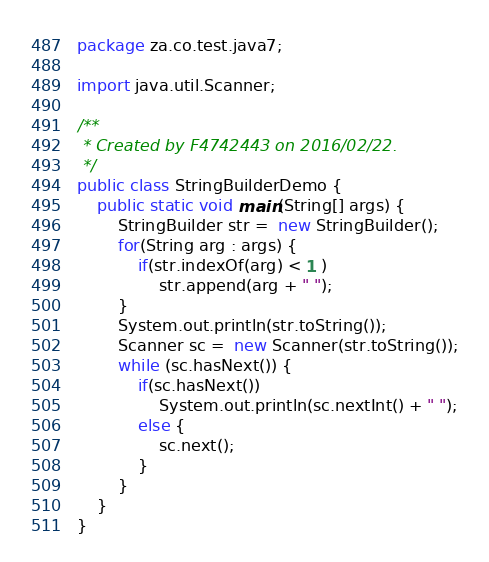Convert code to text. <code><loc_0><loc_0><loc_500><loc_500><_Java_>package za.co.test.java7;

import java.util.Scanner;

/**
 * Created by F4742443 on 2016/02/22.
 */
public class StringBuilderDemo {
    public static void main(String[] args) {
        StringBuilder str =  new StringBuilder();
        for(String arg : args) {
            if(str.indexOf(arg) < 1 )
                str.append(arg + " ");
        }
        System.out.println(str.toString());
        Scanner sc =  new Scanner(str.toString());
        while (sc.hasNext()) {
            if(sc.hasNext())
                System.out.println(sc.nextInt() + " ");
            else {
                sc.next();
            }
        }
    }
}
</code> 